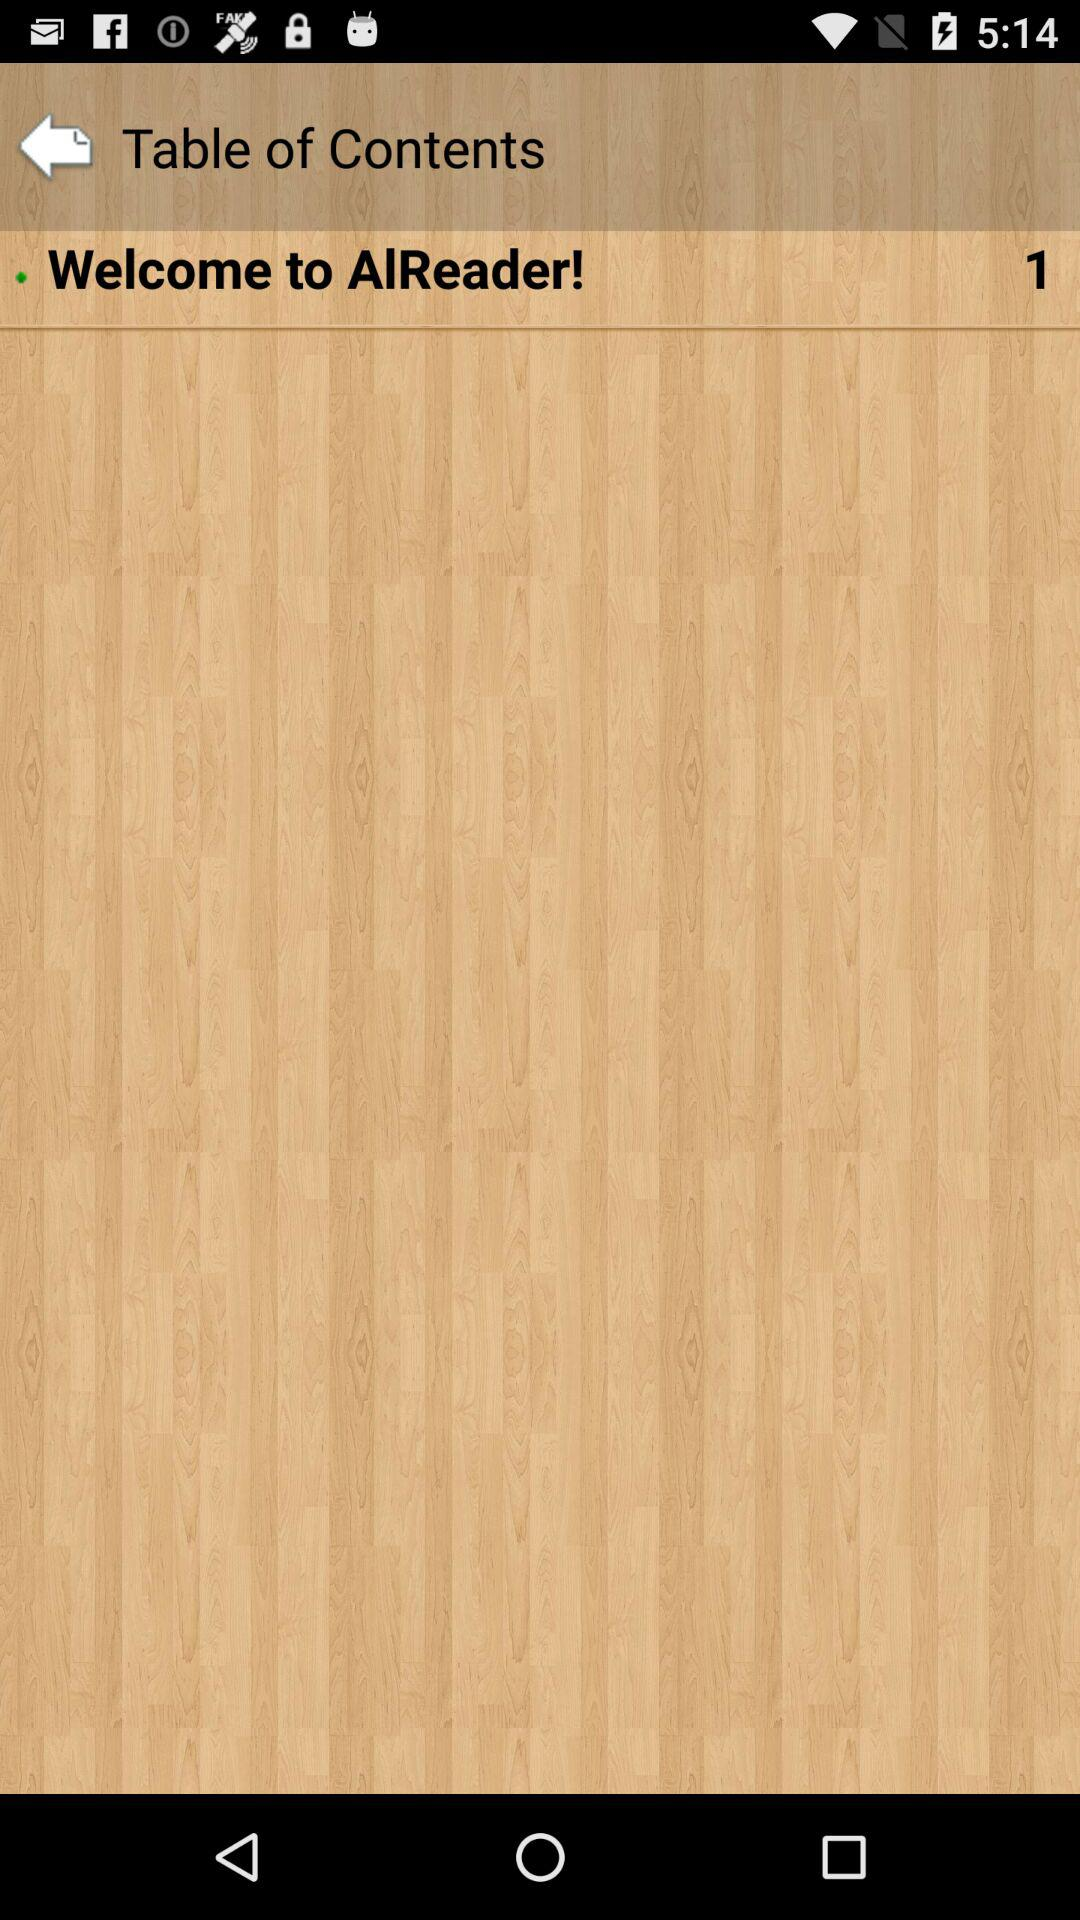What is the number of items in "Welcome to AlReader!"? The number of items in "Welcome to AlReader!" is 1. 